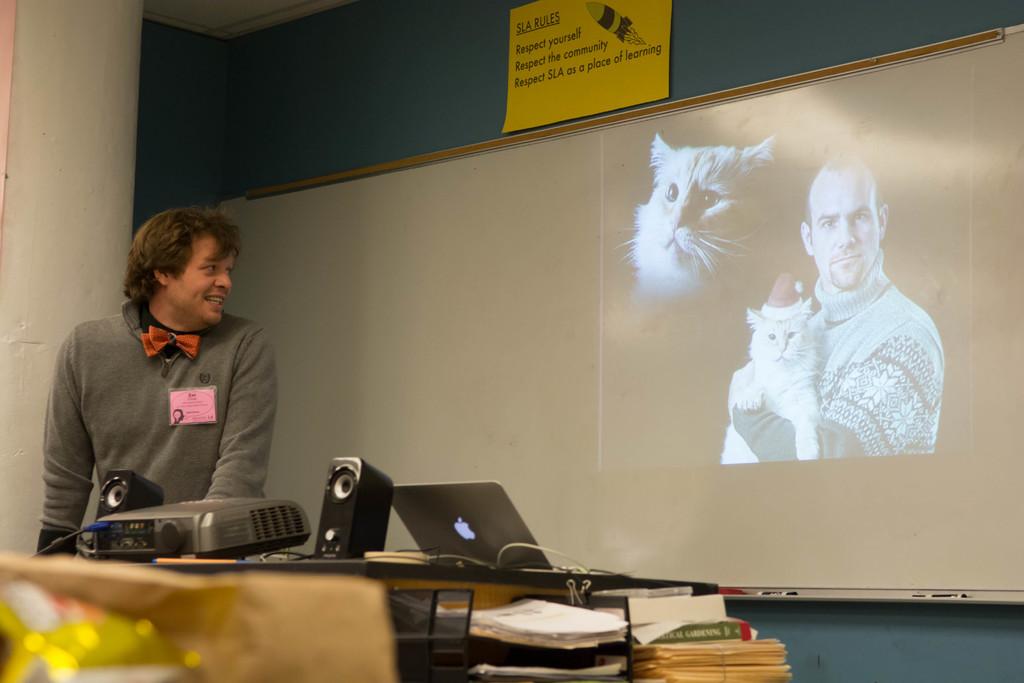What is the first rule listed at the top?
Provide a short and direct response. Respect yourself. What kind of rules are displayed on the top/?
Your answer should be very brief. Sla rules. 